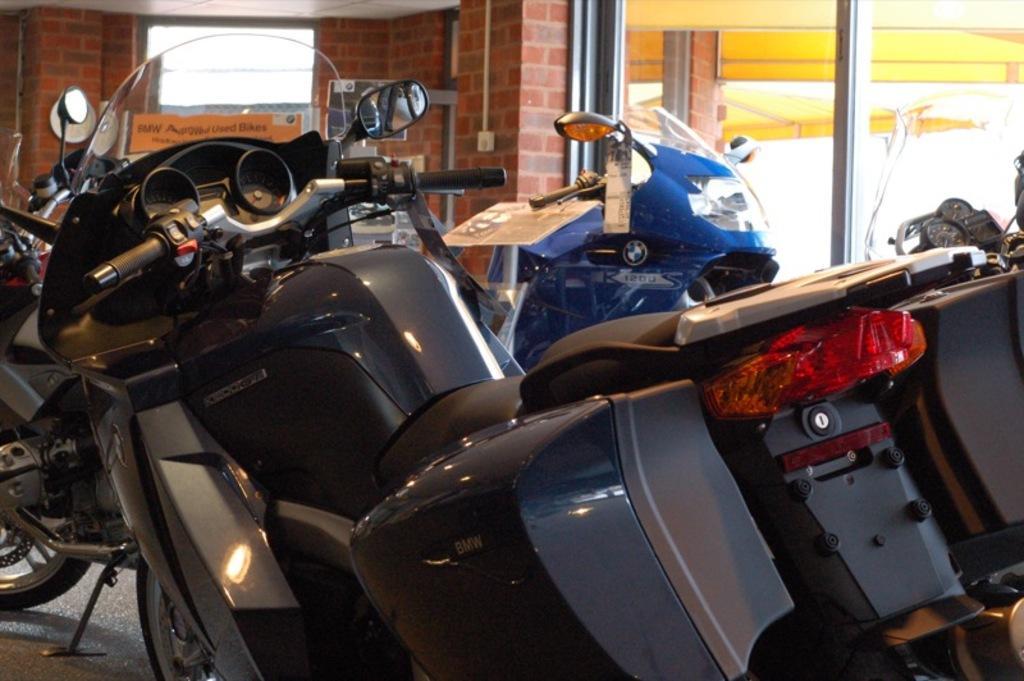How would you summarize this image in a sentence or two? This picture is taken inside the room. In this image, we can see few bikes. In the background, we can see a glass door and a brick wall and a hoarding, outside of the glass door, we can see a brick wall and a roof. 